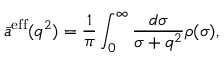<formula> <loc_0><loc_0><loc_500><loc_500>\bar { a } ^ { e f f } ( q ^ { 2 } ) = { \frac { 1 } { \pi } } \int _ { 0 } ^ { \infty } { \frac { d \sigma } { \sigma + q ^ { 2 } } } \rho ( \sigma ) ,</formula> 